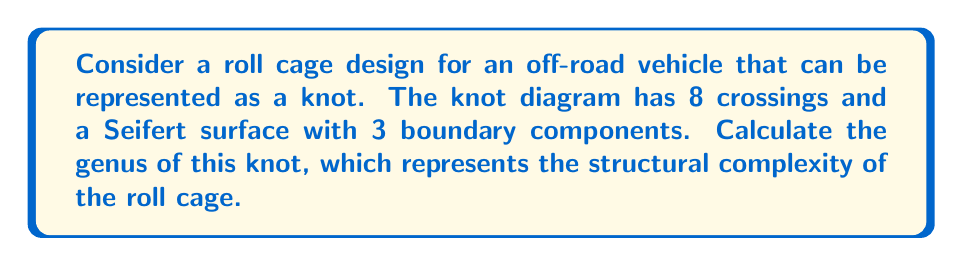Give your solution to this math problem. To determine the genus of the knot representing the roll cage structure, we'll use the following steps:

1. Recall the formula for the genus of a knot:
   $$ g = \frac{1}{2}(c - s + 1) $$
   where $g$ is the genus, $c$ is the number of crossings, and $s$ is the number of Seifert circles.

2. We're given that the knot has 8 crossings, so $c = 8$.

3. To find $s$, we can use the relationship between the number of boundary components ($b$) of the Seifert surface and the number of Seifert circles:
   $$ s = b + 1 $$

4. We're told that the Seifert surface has 3 boundary components, so $b = 3$.

5. Calculate $s$:
   $$ s = 3 + 1 = 4 $$

6. Now we can substitute these values into the genus formula:
   $$ g = \frac{1}{2}(8 - 4 + 1) = \frac{1}{2}(5) = \frac{5}{2} $$

7. Since the genus must be an integer, we round up to the nearest whole number.

Therefore, the genus of the knot representing the roll cage structure is 3.
Answer: 3 